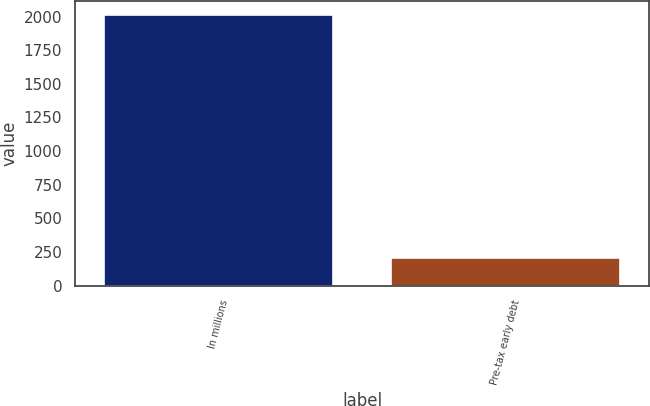Convert chart. <chart><loc_0><loc_0><loc_500><loc_500><bar_chart><fcel>In millions<fcel>Pre-tax early debt<nl><fcel>2015<fcel>207<nl></chart> 